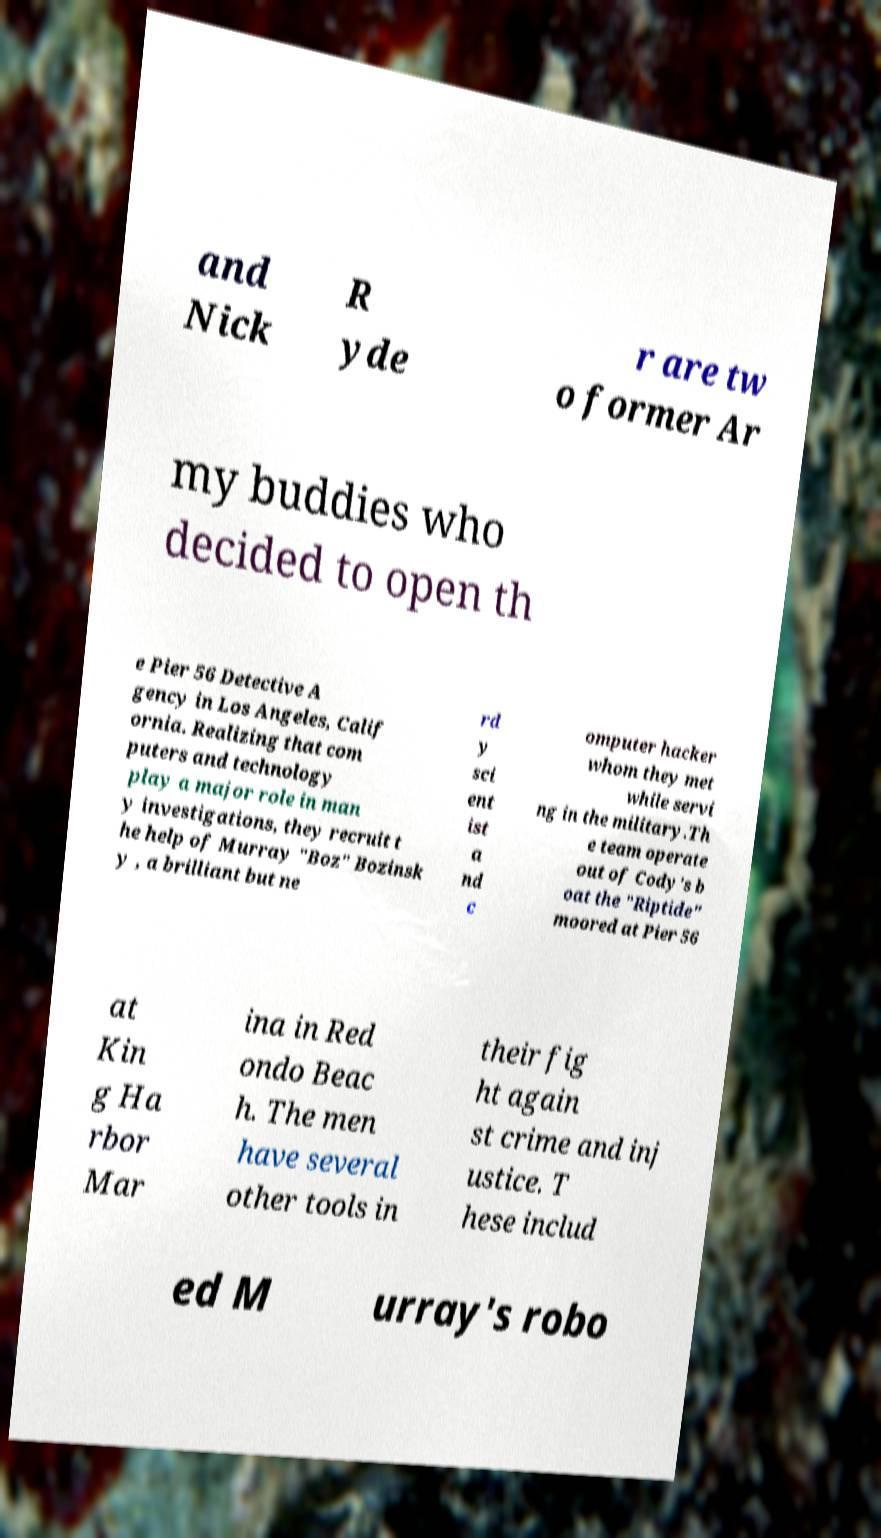Can you accurately transcribe the text from the provided image for me? and Nick R yde r are tw o former Ar my buddies who decided to open th e Pier 56 Detective A gency in Los Angeles, Calif ornia. Realizing that com puters and technology play a major role in man y investigations, they recruit t he help of Murray "Boz" Bozinsk y , a brilliant but ne rd y sci ent ist a nd c omputer hacker whom they met while servi ng in the military.Th e team operate out of Cody's b oat the "Riptide" moored at Pier 56 at Kin g Ha rbor Mar ina in Red ondo Beac h. The men have several other tools in their fig ht again st crime and inj ustice. T hese includ ed M urray's robo 